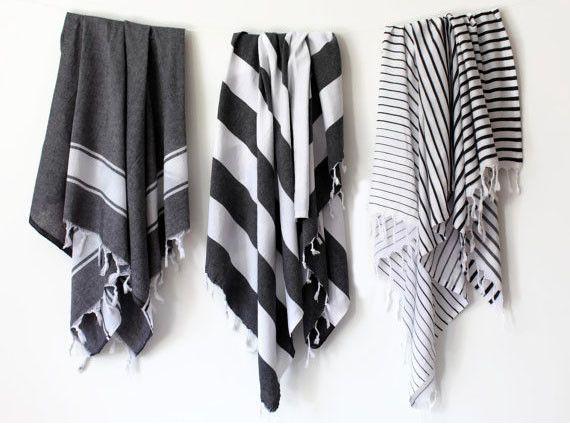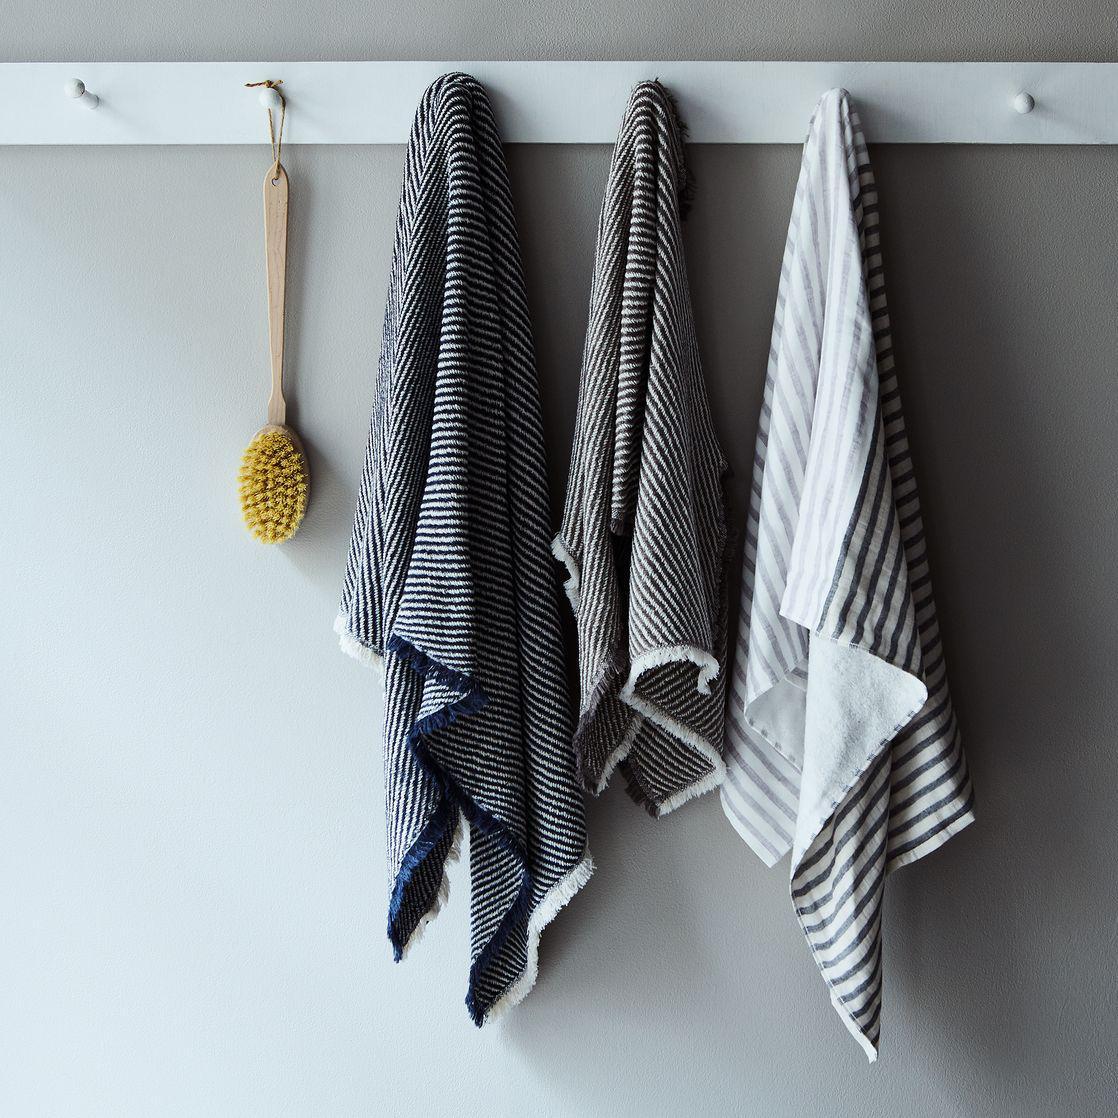The first image is the image on the left, the second image is the image on the right. Assess this claim about the two images: "An equal number of towels is hanging in each image.". Correct or not? Answer yes or no. Yes. 